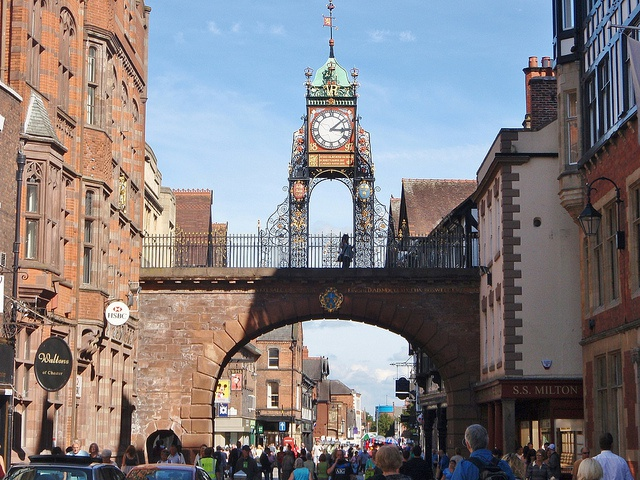Describe the objects in this image and their specific colors. I can see people in brown, black, gray, maroon, and lightgray tones, car in brown, black, navy, gray, and blue tones, people in brown, black, navy, gray, and darkblue tones, people in brown, black, and gray tones, and clock in brown, white, darkgray, and gray tones in this image. 